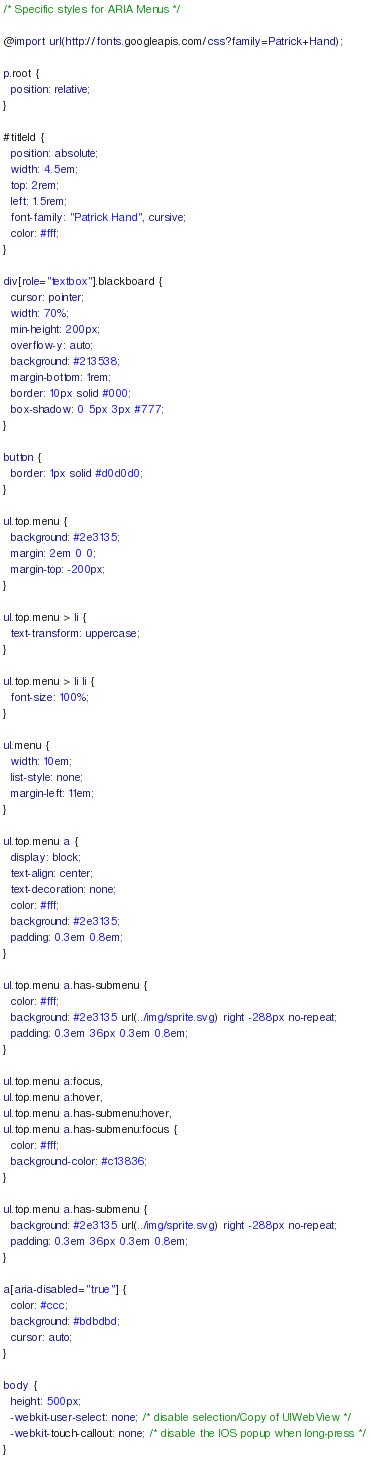<code> <loc_0><loc_0><loc_500><loc_500><_CSS_>/* Specific styles for ARIA Menus */

@import url(http://fonts.googleapis.com/css?family=Patrick+Hand);

p.root {
  position: relative;
}

#titleId {
  position: absolute;
  width: 4.5em;
  top: 2rem;
  left: 1.5rem;
  font-family: "Patrick Hand", cursive;
  color: #fff;
}

div[role="textbox"].blackboard {
  cursor: pointer;
  width: 70%;
  min-height: 200px;
  overflow-y: auto;
  background: #213538;
  margin-bottom: 1rem;
  border: 10px solid #000;
  box-shadow: 0 5px 3px #777;
}

button {
  border: 1px solid #d0d0d0;
}

ul.top.menu {
  background: #2e3135;
  margin: 2em 0 0;
  margin-top: -200px;
}

ul.top.menu > li {
  text-transform: uppercase;
}

ul.top.menu > li li {
  font-size: 100%;
}

ul.menu {
  width: 10em;
  list-style: none;
  margin-left: 11em;
}

ul.top.menu a {
  display: block;
  text-align: center;
  text-decoration: none;
  color: #fff;
  background: #2e3135;
  padding: 0.3em 0.8em;
}

ul.top.menu a.has-submenu {
  color: #fff;
  background: #2e3135 url(../img/sprite.svg) right -288px no-repeat;
  padding: 0.3em 36px 0.3em 0.8em;
}

ul.top.menu a:focus,
ul.top.menu a:hover,
ul.top.menu a.has-submenu:hover,
ul.top.menu a.has-submenu:focus {
  color: #fff;
  background-color: #c13836;
}

ul.top.menu a.has-submenu {
  background: #2e3135 url(../img/sprite.svg) right -288px no-repeat;
  padding: 0.3em 36px 0.3em 0.8em;
}

a[aria-disabled="true"] {
  color: #ccc;
  background: #bdbdbd;
  cursor: auto;
}

body {
  height: 500px;
  -webkit-user-select: none; /* disable selection/Copy of UIWebView */
  -webkit-touch-callout: none; /* disable the IOS popup when long-press */
}
</code> 